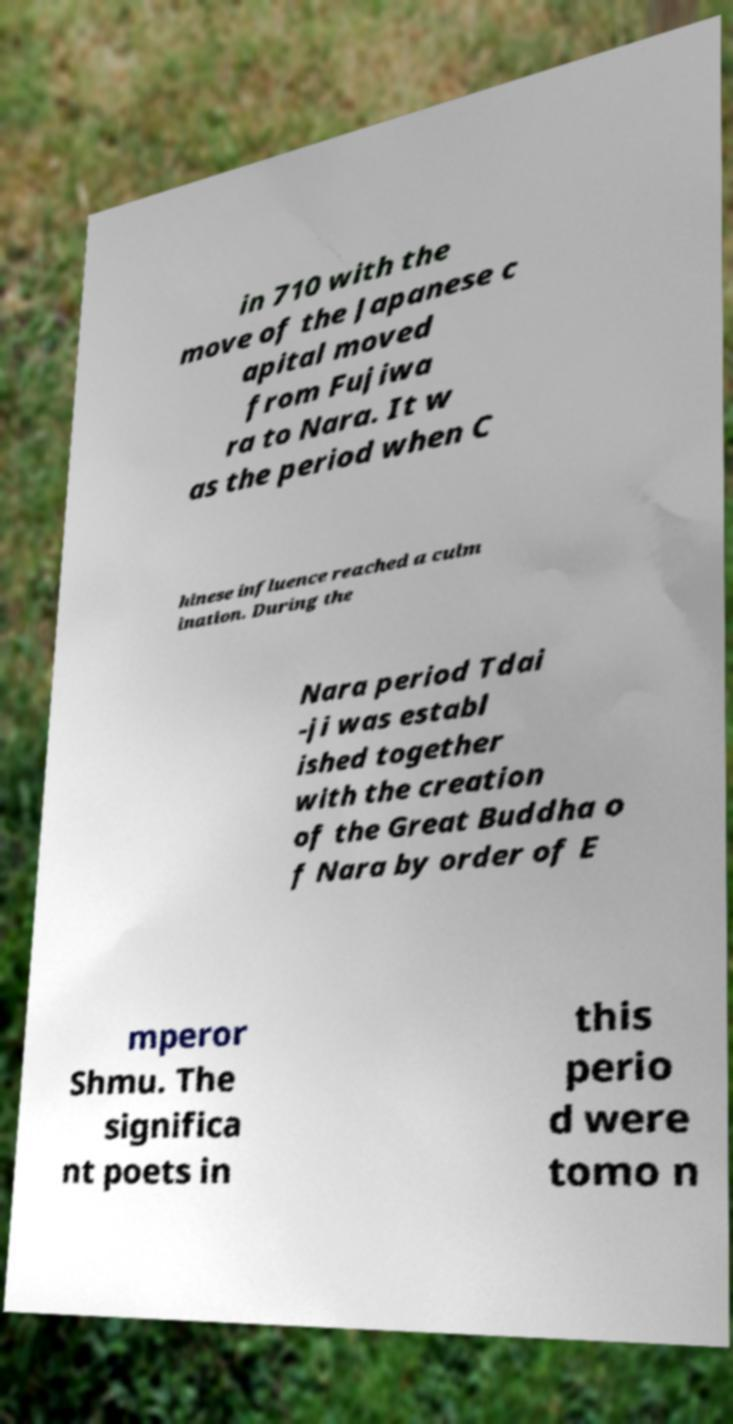Could you extract and type out the text from this image? in 710 with the move of the Japanese c apital moved from Fujiwa ra to Nara. It w as the period when C hinese influence reached a culm ination. During the Nara period Tdai -ji was establ ished together with the creation of the Great Buddha o f Nara by order of E mperor Shmu. The significa nt poets in this perio d were tomo n 